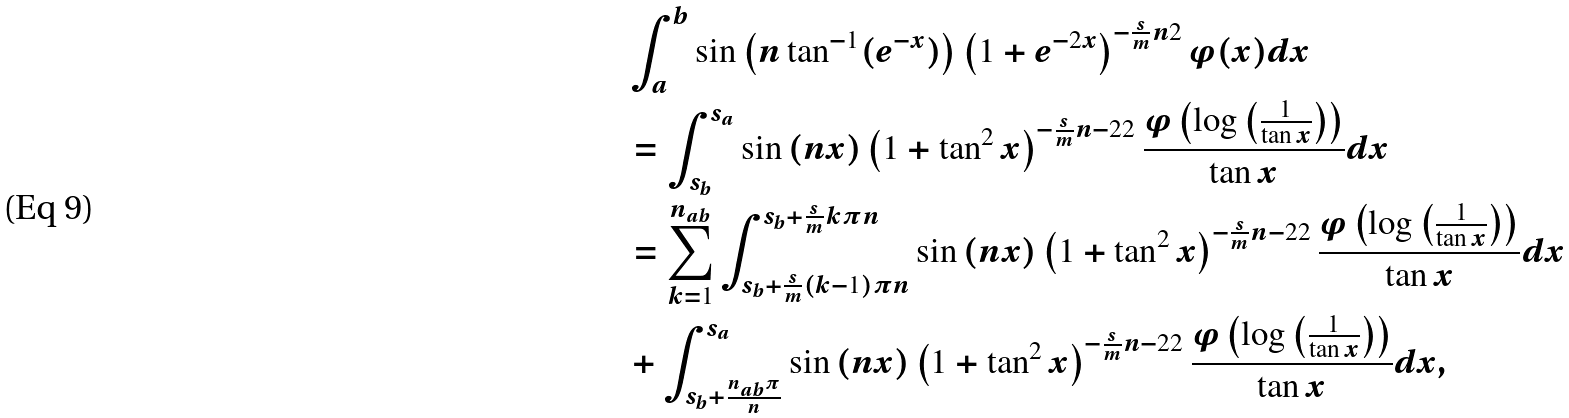<formula> <loc_0><loc_0><loc_500><loc_500>& \int _ { a } ^ { b } \sin \left ( n \tan ^ { - 1 } ( e ^ { - x } ) \right ) \left ( 1 + e ^ { - 2 x } \right ) ^ { - \frac { s } { m } { n } { 2 } } \varphi ( x ) d x \\ & = \int _ { s _ { b } } ^ { s _ { a } } \sin \left ( n x \right ) \left ( 1 + \tan ^ { 2 } x \right ) ^ { - \frac { s } { m } { n - 2 } { 2 } } \frac { \varphi \left ( \log \left ( \frac { 1 } { \tan x } \right ) \right ) } { \tan x } d x \\ & = \sum _ { k = 1 } ^ { n _ { a b } } \int _ { s _ { b } + \frac { s } { m } { ( k - 1 ) \pi } { n } } ^ { s _ { b } + \frac { s } { m } { k \pi } { n } } \sin \left ( n x \right ) \left ( 1 + \tan ^ { 2 } x \right ) ^ { - \frac { s } { m } { n - 2 } { 2 } } \frac { \varphi \left ( \log \left ( \frac { 1 } { \tan x } \right ) \right ) } { \tan x } d x \\ & + \int _ { s _ { b } + \frac { n _ { a b } \pi } { n } } ^ { s _ { a } } \sin \left ( n x \right ) \left ( 1 + \tan ^ { 2 } x \right ) ^ { - \frac { s } { m } { n - 2 } { 2 } } \frac { \varphi \left ( \log \left ( \frac { 1 } { \tan x } \right ) \right ) } { \tan x } d x ,</formula> 